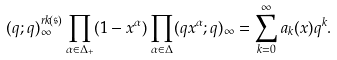<formula> <loc_0><loc_0><loc_500><loc_500>( q ; q ) _ { \infty } ^ { r k ( \mathfrak { s } ) } \prod _ { \alpha \in \Delta _ { + } } ( 1 - x ^ { \alpha } ) \prod _ { \alpha \in \Delta } ( q x ^ { \alpha } ; q ) _ { \infty } & = \sum _ { k = 0 } ^ { \infty } a _ { k } ( x ) q ^ { k } .</formula> 